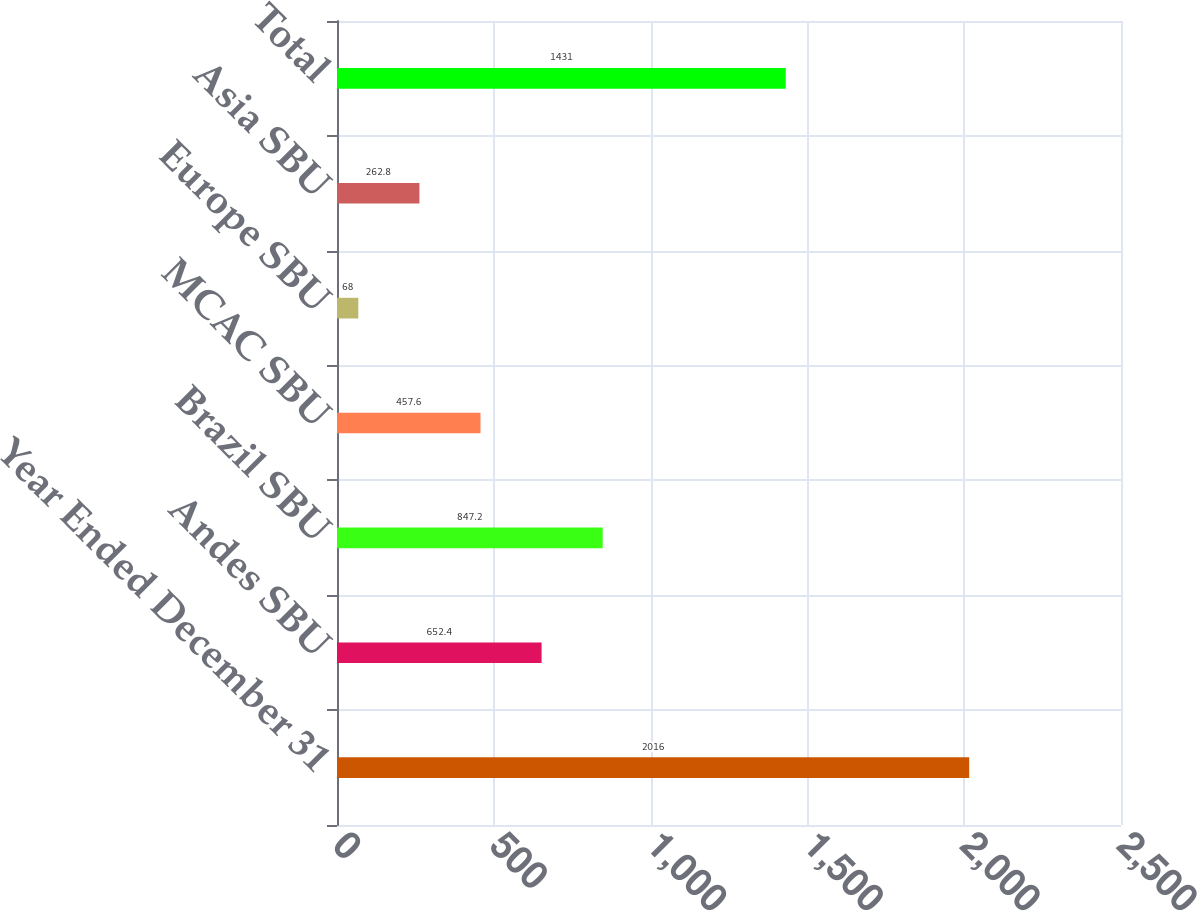Convert chart. <chart><loc_0><loc_0><loc_500><loc_500><bar_chart><fcel>Year Ended December 31<fcel>Andes SBU<fcel>Brazil SBU<fcel>MCAC SBU<fcel>Europe SBU<fcel>Asia SBU<fcel>Total<nl><fcel>2016<fcel>652.4<fcel>847.2<fcel>457.6<fcel>68<fcel>262.8<fcel>1431<nl></chart> 